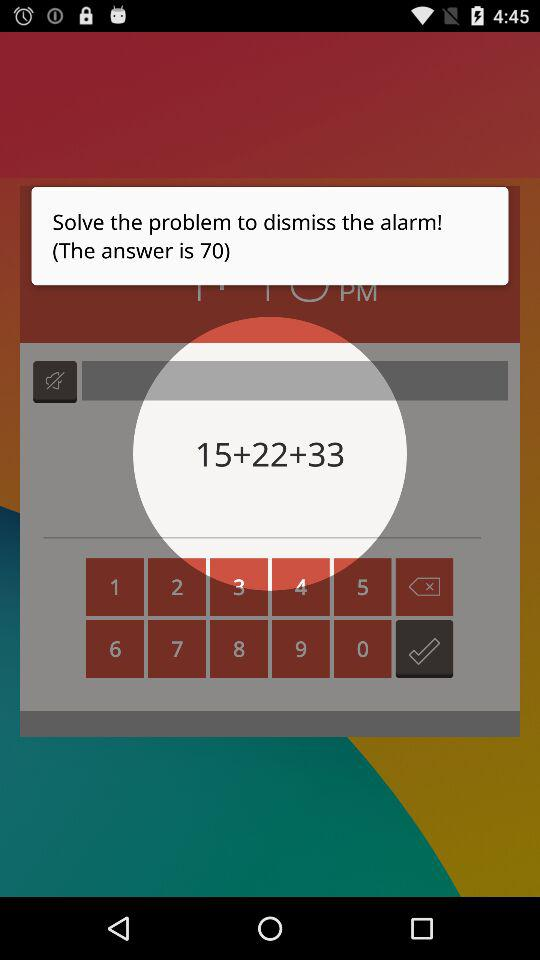What is the sum of the numbers in the equation?
Answer the question using a single word or phrase. 70 